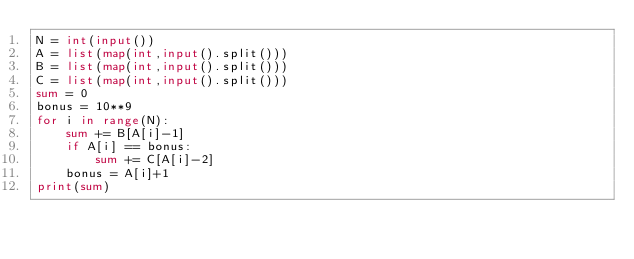<code> <loc_0><loc_0><loc_500><loc_500><_Python_>N = int(input())
A = list(map(int,input().split()))
B = list(map(int,input().split()))
C = list(map(int,input().split()))
sum = 0
bonus = 10**9
for i in range(N):
    sum += B[A[i]-1]
    if A[i] == bonus:
        sum += C[A[i]-2]
    bonus = A[i]+1
print(sum)</code> 